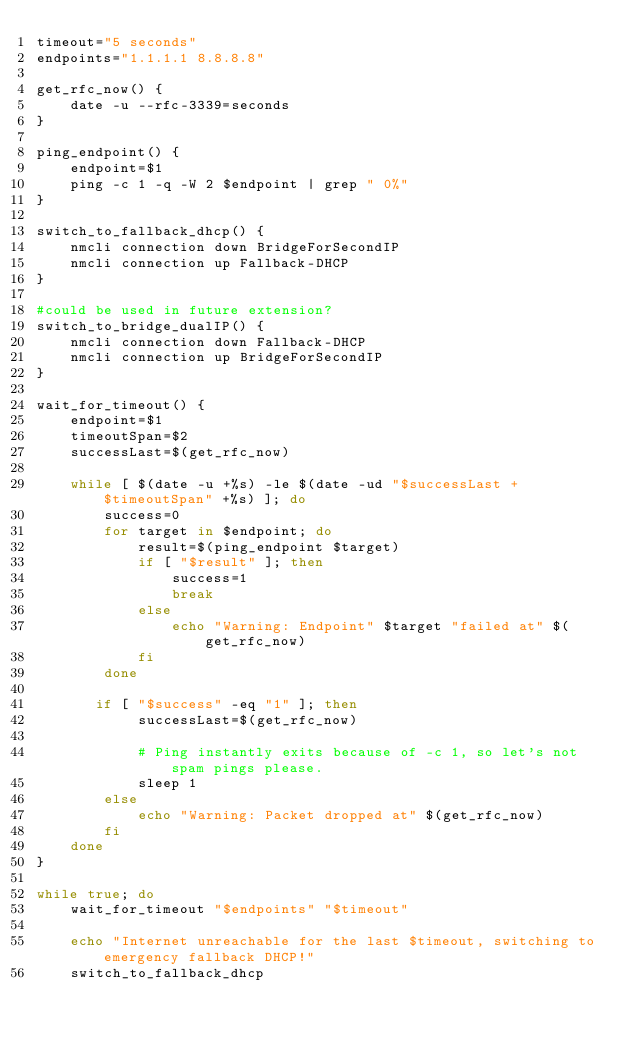Convert code to text. <code><loc_0><loc_0><loc_500><loc_500><_Bash_>timeout="5 seconds"
endpoints="1.1.1.1 8.8.8.8"

get_rfc_now() {
    date -u --rfc-3339=seconds
}

ping_endpoint() {
    endpoint=$1
    ping -c 1 -q -W 2 $endpoint | grep " 0%"
}

switch_to_fallback_dhcp() {
    nmcli connection down BridgeForSecondIP
    nmcli connection up Fallback-DHCP
}

#could be used in future extension?
switch_to_bridge_dualIP() {
    nmcli connection down Fallback-DHCP
    nmcli connection up BridgeForSecondIP
}

wait_for_timeout() {
    endpoint=$1
    timeoutSpan=$2
    successLast=$(get_rfc_now)

    while [ $(date -u +%s) -le $(date -ud "$successLast +$timeoutSpan" +%s) ]; do
        success=0
        for target in $endpoint; do
            result=$(ping_endpoint $target)
            if [ "$result" ]; then
                success=1
                break
            else
                echo "Warning: Endpoint" $target "failed at" $(get_rfc_now)
            fi
        done

       if [ "$success" -eq "1" ]; then
            successLast=$(get_rfc_now)

            # Ping instantly exits because of -c 1, so let's not spam pings please.
            sleep 1
        else
            echo "Warning: Packet dropped at" $(get_rfc_now)
        fi
    done
}

while true; do
    wait_for_timeout "$endpoints" "$timeout"

    echo "Internet unreachable for the last $timeout, switching to emergency fallback DHCP!"
    switch_to_fallback_dhcp</code> 